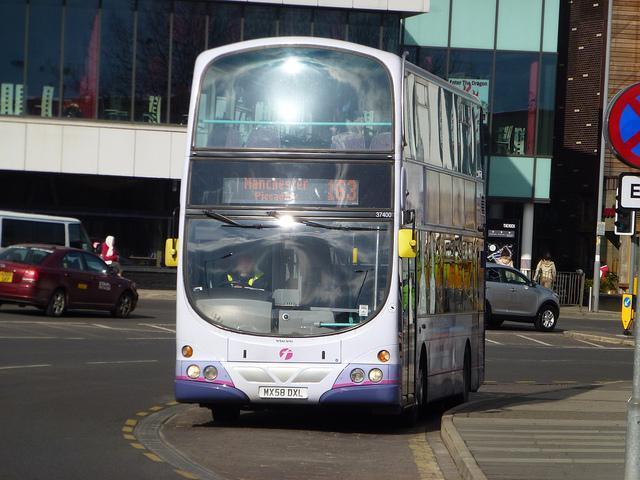How many levels does the bus have?
Give a very brief answer. 2. How many vehicles are in the picture?
Give a very brief answer. 4. How many cars can be seen?
Give a very brief answer. 3. How many trains have a number on the front?
Give a very brief answer. 0. 